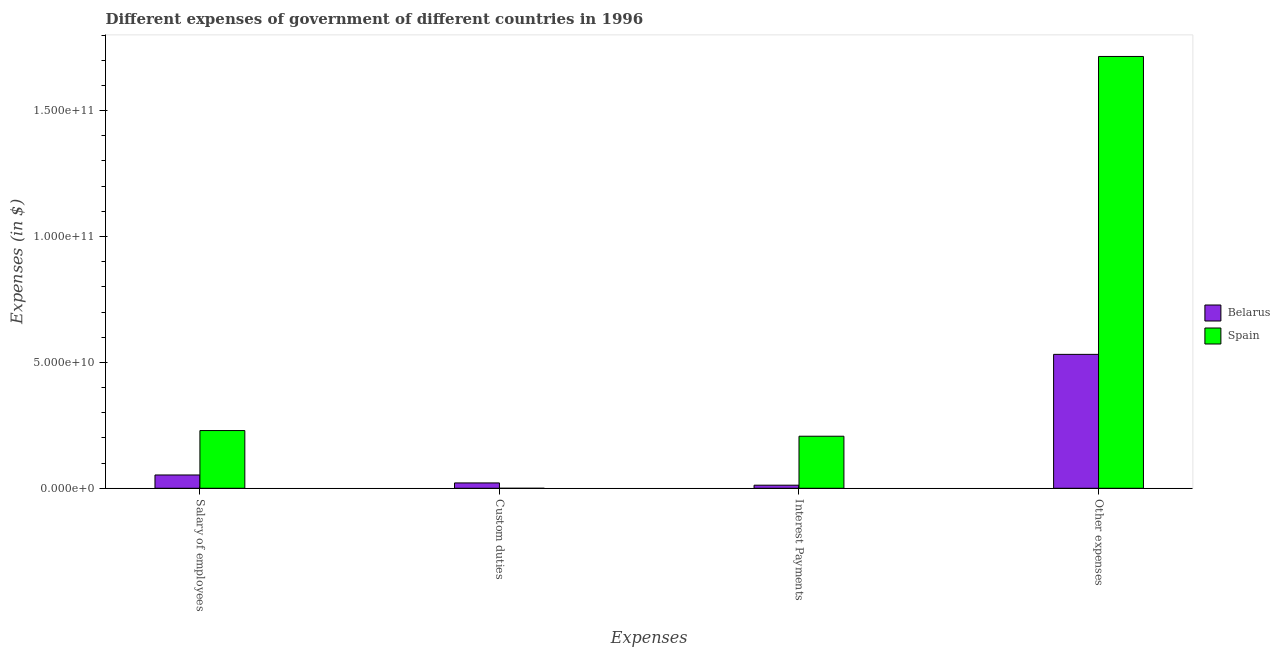How many different coloured bars are there?
Give a very brief answer. 2. Are the number of bars on each tick of the X-axis equal?
Offer a terse response. No. What is the label of the 3rd group of bars from the left?
Your response must be concise. Interest Payments. What is the amount spent on salary of employees in Spain?
Provide a short and direct response. 2.29e+1. Across all countries, what is the maximum amount spent on custom duties?
Ensure brevity in your answer.  2.12e+09. Across all countries, what is the minimum amount spent on interest payments?
Provide a succinct answer. 1.23e+09. In which country was the amount spent on other expenses maximum?
Your answer should be compact. Spain. What is the total amount spent on other expenses in the graph?
Provide a succinct answer. 2.25e+11. What is the difference between the amount spent on salary of employees in Belarus and that in Spain?
Offer a terse response. -1.76e+1. What is the difference between the amount spent on salary of employees in Spain and the amount spent on other expenses in Belarus?
Give a very brief answer. -3.03e+1. What is the average amount spent on salary of employees per country?
Your answer should be very brief. 1.41e+1. What is the difference between the amount spent on other expenses and amount spent on interest payments in Spain?
Provide a succinct answer. 1.51e+11. In how many countries, is the amount spent on other expenses greater than 60000000000 $?
Provide a succinct answer. 1. What is the ratio of the amount spent on other expenses in Spain to that in Belarus?
Ensure brevity in your answer.  3.22. Is the amount spent on other expenses in Belarus less than that in Spain?
Give a very brief answer. Yes. Is the difference between the amount spent on interest payments in Belarus and Spain greater than the difference between the amount spent on other expenses in Belarus and Spain?
Give a very brief answer. Yes. What is the difference between the highest and the second highest amount spent on salary of employees?
Your answer should be compact. 1.76e+1. What is the difference between the highest and the lowest amount spent on interest payments?
Offer a very short reply. 1.94e+1. Is it the case that in every country, the sum of the amount spent on other expenses and amount spent on interest payments is greater than the sum of amount spent on custom duties and amount spent on salary of employees?
Provide a short and direct response. No. Are all the bars in the graph horizontal?
Give a very brief answer. No. How many countries are there in the graph?
Give a very brief answer. 2. Are the values on the major ticks of Y-axis written in scientific E-notation?
Provide a short and direct response. Yes. Where does the legend appear in the graph?
Your answer should be compact. Center right. How many legend labels are there?
Offer a terse response. 2. How are the legend labels stacked?
Provide a succinct answer. Vertical. What is the title of the graph?
Your response must be concise. Different expenses of government of different countries in 1996. Does "Ghana" appear as one of the legend labels in the graph?
Ensure brevity in your answer.  No. What is the label or title of the X-axis?
Provide a short and direct response. Expenses. What is the label or title of the Y-axis?
Your answer should be compact. Expenses (in $). What is the Expenses (in $) of Belarus in Salary of employees?
Provide a short and direct response. 5.28e+09. What is the Expenses (in $) in Spain in Salary of employees?
Provide a succinct answer. 2.29e+1. What is the Expenses (in $) in Belarus in Custom duties?
Offer a very short reply. 2.12e+09. What is the Expenses (in $) of Spain in Custom duties?
Give a very brief answer. 0. What is the Expenses (in $) in Belarus in Interest Payments?
Provide a short and direct response. 1.23e+09. What is the Expenses (in $) of Spain in Interest Payments?
Ensure brevity in your answer.  2.07e+1. What is the Expenses (in $) of Belarus in Other expenses?
Ensure brevity in your answer.  5.32e+1. What is the Expenses (in $) in Spain in Other expenses?
Keep it short and to the point. 1.71e+11. Across all Expenses, what is the maximum Expenses (in $) in Belarus?
Keep it short and to the point. 5.32e+1. Across all Expenses, what is the maximum Expenses (in $) of Spain?
Your answer should be compact. 1.71e+11. Across all Expenses, what is the minimum Expenses (in $) of Belarus?
Your response must be concise. 1.23e+09. What is the total Expenses (in $) in Belarus in the graph?
Give a very brief answer. 6.18e+1. What is the total Expenses (in $) of Spain in the graph?
Ensure brevity in your answer.  2.15e+11. What is the difference between the Expenses (in $) of Belarus in Salary of employees and that in Custom duties?
Your response must be concise. 3.16e+09. What is the difference between the Expenses (in $) of Belarus in Salary of employees and that in Interest Payments?
Make the answer very short. 4.06e+09. What is the difference between the Expenses (in $) in Spain in Salary of employees and that in Interest Payments?
Provide a succinct answer. 2.25e+09. What is the difference between the Expenses (in $) in Belarus in Salary of employees and that in Other expenses?
Provide a short and direct response. -4.79e+1. What is the difference between the Expenses (in $) in Spain in Salary of employees and that in Other expenses?
Give a very brief answer. -1.49e+11. What is the difference between the Expenses (in $) of Belarus in Custom duties and that in Interest Payments?
Provide a short and direct response. 8.98e+08. What is the difference between the Expenses (in $) in Belarus in Custom duties and that in Other expenses?
Give a very brief answer. -5.11e+1. What is the difference between the Expenses (in $) of Belarus in Interest Payments and that in Other expenses?
Provide a short and direct response. -5.20e+1. What is the difference between the Expenses (in $) of Spain in Interest Payments and that in Other expenses?
Keep it short and to the point. -1.51e+11. What is the difference between the Expenses (in $) of Belarus in Salary of employees and the Expenses (in $) of Spain in Interest Payments?
Provide a short and direct response. -1.54e+1. What is the difference between the Expenses (in $) in Belarus in Salary of employees and the Expenses (in $) in Spain in Other expenses?
Your answer should be compact. -1.66e+11. What is the difference between the Expenses (in $) in Belarus in Custom duties and the Expenses (in $) in Spain in Interest Payments?
Ensure brevity in your answer.  -1.85e+1. What is the difference between the Expenses (in $) in Belarus in Custom duties and the Expenses (in $) in Spain in Other expenses?
Provide a short and direct response. -1.69e+11. What is the difference between the Expenses (in $) in Belarus in Interest Payments and the Expenses (in $) in Spain in Other expenses?
Give a very brief answer. -1.70e+11. What is the average Expenses (in $) in Belarus per Expenses?
Your response must be concise. 1.55e+1. What is the average Expenses (in $) in Spain per Expenses?
Offer a terse response. 5.38e+1. What is the difference between the Expenses (in $) of Belarus and Expenses (in $) of Spain in Salary of employees?
Keep it short and to the point. -1.76e+1. What is the difference between the Expenses (in $) of Belarus and Expenses (in $) of Spain in Interest Payments?
Your answer should be compact. -1.94e+1. What is the difference between the Expenses (in $) in Belarus and Expenses (in $) in Spain in Other expenses?
Provide a succinct answer. -1.18e+11. What is the ratio of the Expenses (in $) in Belarus in Salary of employees to that in Custom duties?
Offer a very short reply. 2.49. What is the ratio of the Expenses (in $) of Belarus in Salary of employees to that in Interest Payments?
Your answer should be very brief. 4.31. What is the ratio of the Expenses (in $) of Spain in Salary of employees to that in Interest Payments?
Your answer should be very brief. 1.11. What is the ratio of the Expenses (in $) in Belarus in Salary of employees to that in Other expenses?
Offer a terse response. 0.1. What is the ratio of the Expenses (in $) of Spain in Salary of employees to that in Other expenses?
Provide a short and direct response. 0.13. What is the ratio of the Expenses (in $) in Belarus in Custom duties to that in Interest Payments?
Provide a short and direct response. 1.73. What is the ratio of the Expenses (in $) of Belarus in Custom duties to that in Other expenses?
Provide a succinct answer. 0.04. What is the ratio of the Expenses (in $) of Belarus in Interest Payments to that in Other expenses?
Offer a very short reply. 0.02. What is the ratio of the Expenses (in $) in Spain in Interest Payments to that in Other expenses?
Your answer should be very brief. 0.12. What is the difference between the highest and the second highest Expenses (in $) in Belarus?
Ensure brevity in your answer.  4.79e+1. What is the difference between the highest and the second highest Expenses (in $) in Spain?
Your answer should be very brief. 1.49e+11. What is the difference between the highest and the lowest Expenses (in $) of Belarus?
Offer a very short reply. 5.20e+1. What is the difference between the highest and the lowest Expenses (in $) of Spain?
Your answer should be very brief. 1.71e+11. 